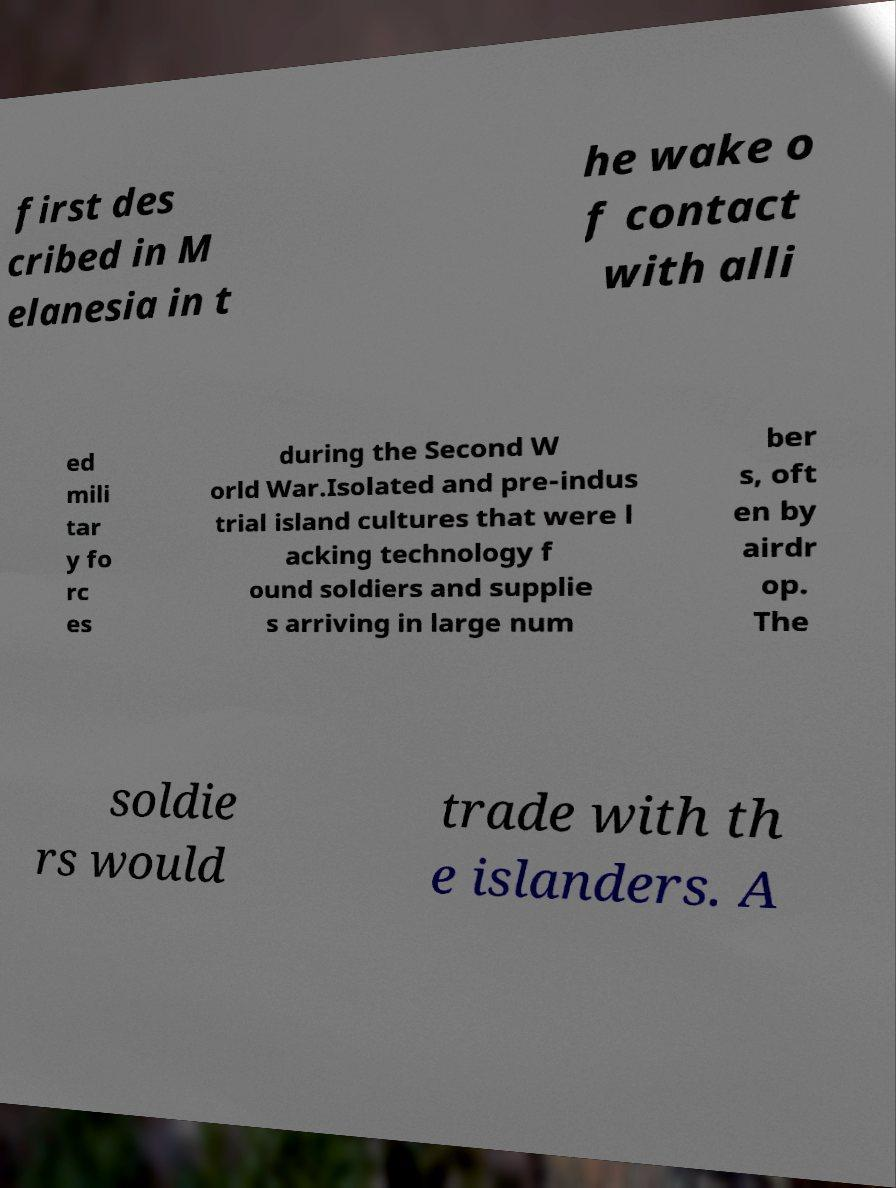Can you accurately transcribe the text from the provided image for me? first des cribed in M elanesia in t he wake o f contact with alli ed mili tar y fo rc es during the Second W orld War.Isolated and pre-indus trial island cultures that were l acking technology f ound soldiers and supplie s arriving in large num ber s, oft en by airdr op. The soldie rs would trade with th e islanders. A 